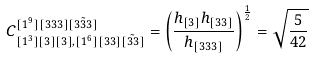Convert formula to latex. <formula><loc_0><loc_0><loc_500><loc_500>C ^ { [ 1 ^ { 9 } ] [ 3 3 3 ] \tilde { [ 3 3 3 ] } } _ { [ 1 ^ { 3 } ] [ 3 ] [ 3 ] , [ 1 ^ { 6 } ] [ 3 3 ] \tilde { [ 3 3 ] } } = \left ( \frac { h _ { [ 3 ] } h _ { [ 3 3 ] } } { h _ { [ 3 3 3 ] } } \right ) ^ { \frac { 1 } { 2 } } = \sqrt { \frac { 5 } { 4 2 } }</formula> 